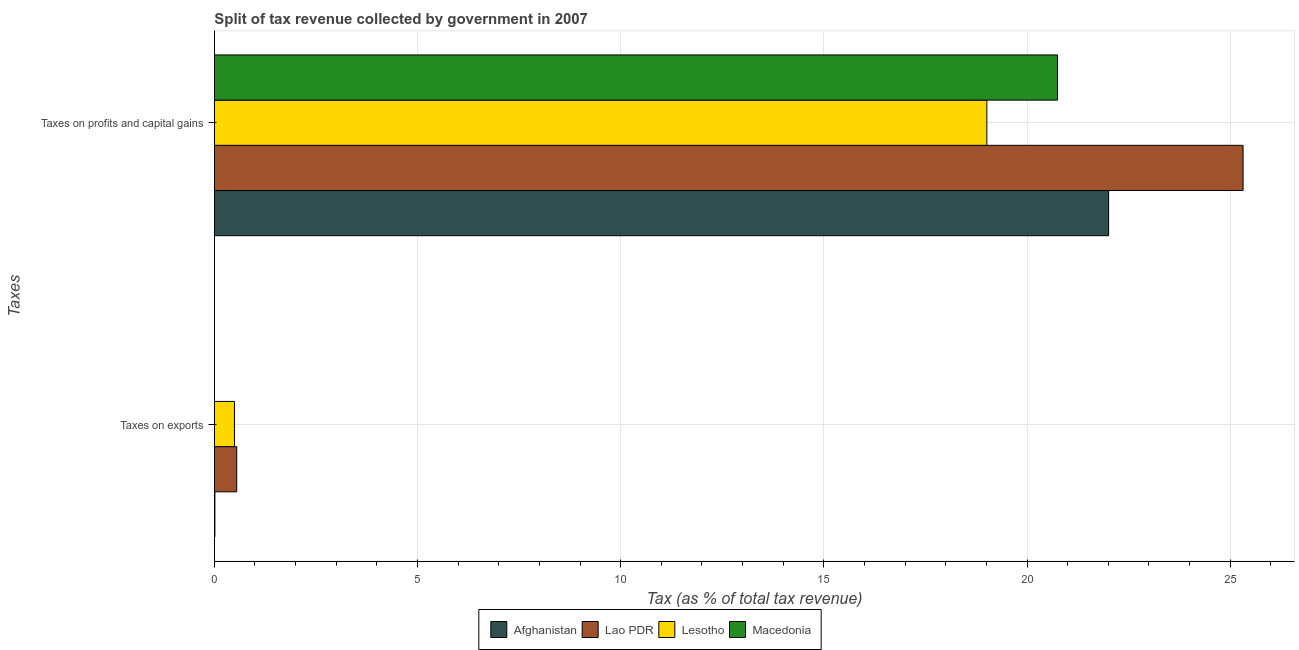Are the number of bars per tick equal to the number of legend labels?
Offer a terse response. Yes. What is the label of the 2nd group of bars from the top?
Ensure brevity in your answer.  Taxes on exports. What is the percentage of revenue obtained from taxes on exports in Lesotho?
Provide a short and direct response. 0.49. Across all countries, what is the maximum percentage of revenue obtained from taxes on exports?
Offer a very short reply. 0.55. Across all countries, what is the minimum percentage of revenue obtained from taxes on profits and capital gains?
Ensure brevity in your answer.  19.01. In which country was the percentage of revenue obtained from taxes on exports maximum?
Offer a terse response. Lao PDR. In which country was the percentage of revenue obtained from taxes on profits and capital gains minimum?
Offer a very short reply. Lesotho. What is the total percentage of revenue obtained from taxes on profits and capital gains in the graph?
Keep it short and to the point. 87.09. What is the difference between the percentage of revenue obtained from taxes on profits and capital gains in Afghanistan and that in Lesotho?
Your answer should be very brief. 3. What is the difference between the percentage of revenue obtained from taxes on profits and capital gains in Afghanistan and the percentage of revenue obtained from taxes on exports in Lesotho?
Your answer should be compact. 21.51. What is the average percentage of revenue obtained from taxes on exports per country?
Offer a very short reply. 0.26. What is the difference between the percentage of revenue obtained from taxes on profits and capital gains and percentage of revenue obtained from taxes on exports in Macedonia?
Make the answer very short. 20.75. In how many countries, is the percentage of revenue obtained from taxes on profits and capital gains greater than 22 %?
Give a very brief answer. 2. What is the ratio of the percentage of revenue obtained from taxes on profits and capital gains in Lao PDR to that in Macedonia?
Provide a short and direct response. 1.22. Is the percentage of revenue obtained from taxes on exports in Macedonia less than that in Lesotho?
Offer a very short reply. Yes. What does the 3rd bar from the top in Taxes on profits and capital gains represents?
Your answer should be compact. Lao PDR. What does the 4th bar from the bottom in Taxes on profits and capital gains represents?
Your answer should be very brief. Macedonia. How many bars are there?
Provide a succinct answer. 8. How many countries are there in the graph?
Your answer should be very brief. 4. Are the values on the major ticks of X-axis written in scientific E-notation?
Ensure brevity in your answer.  No. Does the graph contain grids?
Keep it short and to the point. Yes. Where does the legend appear in the graph?
Your response must be concise. Bottom center. How many legend labels are there?
Provide a succinct answer. 4. What is the title of the graph?
Ensure brevity in your answer.  Split of tax revenue collected by government in 2007. Does "Macao" appear as one of the legend labels in the graph?
Offer a very short reply. No. What is the label or title of the X-axis?
Provide a succinct answer. Tax (as % of total tax revenue). What is the label or title of the Y-axis?
Offer a very short reply. Taxes. What is the Tax (as % of total tax revenue) in Afghanistan in Taxes on exports?
Offer a terse response. 0.01. What is the Tax (as % of total tax revenue) of Lao PDR in Taxes on exports?
Offer a terse response. 0.55. What is the Tax (as % of total tax revenue) of Lesotho in Taxes on exports?
Give a very brief answer. 0.49. What is the Tax (as % of total tax revenue) in Macedonia in Taxes on exports?
Make the answer very short. 1.83851793347189e-5. What is the Tax (as % of total tax revenue) in Afghanistan in Taxes on profits and capital gains?
Your answer should be compact. 22.01. What is the Tax (as % of total tax revenue) in Lao PDR in Taxes on profits and capital gains?
Your answer should be very brief. 25.32. What is the Tax (as % of total tax revenue) of Lesotho in Taxes on profits and capital gains?
Your response must be concise. 19.01. What is the Tax (as % of total tax revenue) in Macedonia in Taxes on profits and capital gains?
Offer a terse response. 20.75. Across all Taxes, what is the maximum Tax (as % of total tax revenue) of Afghanistan?
Give a very brief answer. 22.01. Across all Taxes, what is the maximum Tax (as % of total tax revenue) in Lao PDR?
Offer a very short reply. 25.32. Across all Taxes, what is the maximum Tax (as % of total tax revenue) of Lesotho?
Ensure brevity in your answer.  19.01. Across all Taxes, what is the maximum Tax (as % of total tax revenue) of Macedonia?
Your response must be concise. 20.75. Across all Taxes, what is the minimum Tax (as % of total tax revenue) in Afghanistan?
Provide a short and direct response. 0.01. Across all Taxes, what is the minimum Tax (as % of total tax revenue) in Lao PDR?
Offer a terse response. 0.55. Across all Taxes, what is the minimum Tax (as % of total tax revenue) of Lesotho?
Offer a terse response. 0.49. Across all Taxes, what is the minimum Tax (as % of total tax revenue) of Macedonia?
Your answer should be compact. 1.83851793347189e-5. What is the total Tax (as % of total tax revenue) of Afghanistan in the graph?
Ensure brevity in your answer.  22.02. What is the total Tax (as % of total tax revenue) in Lao PDR in the graph?
Make the answer very short. 25.87. What is the total Tax (as % of total tax revenue) in Lesotho in the graph?
Your answer should be very brief. 19.51. What is the total Tax (as % of total tax revenue) of Macedonia in the graph?
Your answer should be compact. 20.75. What is the difference between the Tax (as % of total tax revenue) in Afghanistan in Taxes on exports and that in Taxes on profits and capital gains?
Your answer should be compact. -22. What is the difference between the Tax (as % of total tax revenue) of Lao PDR in Taxes on exports and that in Taxes on profits and capital gains?
Offer a very short reply. -24.77. What is the difference between the Tax (as % of total tax revenue) of Lesotho in Taxes on exports and that in Taxes on profits and capital gains?
Give a very brief answer. -18.52. What is the difference between the Tax (as % of total tax revenue) of Macedonia in Taxes on exports and that in Taxes on profits and capital gains?
Provide a short and direct response. -20.75. What is the difference between the Tax (as % of total tax revenue) in Afghanistan in Taxes on exports and the Tax (as % of total tax revenue) in Lao PDR in Taxes on profits and capital gains?
Provide a short and direct response. -25.3. What is the difference between the Tax (as % of total tax revenue) in Afghanistan in Taxes on exports and the Tax (as % of total tax revenue) in Lesotho in Taxes on profits and capital gains?
Your answer should be very brief. -19. What is the difference between the Tax (as % of total tax revenue) in Afghanistan in Taxes on exports and the Tax (as % of total tax revenue) in Macedonia in Taxes on profits and capital gains?
Give a very brief answer. -20.74. What is the difference between the Tax (as % of total tax revenue) in Lao PDR in Taxes on exports and the Tax (as % of total tax revenue) in Lesotho in Taxes on profits and capital gains?
Your answer should be very brief. -18.46. What is the difference between the Tax (as % of total tax revenue) of Lao PDR in Taxes on exports and the Tax (as % of total tax revenue) of Macedonia in Taxes on profits and capital gains?
Your answer should be very brief. -20.2. What is the difference between the Tax (as % of total tax revenue) in Lesotho in Taxes on exports and the Tax (as % of total tax revenue) in Macedonia in Taxes on profits and capital gains?
Keep it short and to the point. -20.26. What is the average Tax (as % of total tax revenue) of Afghanistan per Taxes?
Your response must be concise. 11.01. What is the average Tax (as % of total tax revenue) in Lao PDR per Taxes?
Ensure brevity in your answer.  12.93. What is the average Tax (as % of total tax revenue) of Lesotho per Taxes?
Offer a very short reply. 9.75. What is the average Tax (as % of total tax revenue) of Macedonia per Taxes?
Ensure brevity in your answer.  10.38. What is the difference between the Tax (as % of total tax revenue) of Afghanistan and Tax (as % of total tax revenue) of Lao PDR in Taxes on exports?
Offer a very short reply. -0.54. What is the difference between the Tax (as % of total tax revenue) in Afghanistan and Tax (as % of total tax revenue) in Lesotho in Taxes on exports?
Provide a succinct answer. -0.48. What is the difference between the Tax (as % of total tax revenue) in Afghanistan and Tax (as % of total tax revenue) in Macedonia in Taxes on exports?
Give a very brief answer. 0.01. What is the difference between the Tax (as % of total tax revenue) in Lao PDR and Tax (as % of total tax revenue) in Lesotho in Taxes on exports?
Provide a short and direct response. 0.06. What is the difference between the Tax (as % of total tax revenue) in Lao PDR and Tax (as % of total tax revenue) in Macedonia in Taxes on exports?
Offer a very short reply. 0.55. What is the difference between the Tax (as % of total tax revenue) in Lesotho and Tax (as % of total tax revenue) in Macedonia in Taxes on exports?
Your answer should be compact. 0.49. What is the difference between the Tax (as % of total tax revenue) in Afghanistan and Tax (as % of total tax revenue) in Lao PDR in Taxes on profits and capital gains?
Your response must be concise. -3.31. What is the difference between the Tax (as % of total tax revenue) in Afghanistan and Tax (as % of total tax revenue) in Lesotho in Taxes on profits and capital gains?
Your response must be concise. 3. What is the difference between the Tax (as % of total tax revenue) in Afghanistan and Tax (as % of total tax revenue) in Macedonia in Taxes on profits and capital gains?
Offer a terse response. 1.26. What is the difference between the Tax (as % of total tax revenue) in Lao PDR and Tax (as % of total tax revenue) in Lesotho in Taxes on profits and capital gains?
Give a very brief answer. 6.3. What is the difference between the Tax (as % of total tax revenue) of Lao PDR and Tax (as % of total tax revenue) of Macedonia in Taxes on profits and capital gains?
Your answer should be very brief. 4.57. What is the difference between the Tax (as % of total tax revenue) of Lesotho and Tax (as % of total tax revenue) of Macedonia in Taxes on profits and capital gains?
Provide a short and direct response. -1.74. What is the ratio of the Tax (as % of total tax revenue) in Afghanistan in Taxes on exports to that in Taxes on profits and capital gains?
Offer a very short reply. 0. What is the ratio of the Tax (as % of total tax revenue) of Lao PDR in Taxes on exports to that in Taxes on profits and capital gains?
Your answer should be very brief. 0.02. What is the ratio of the Tax (as % of total tax revenue) in Lesotho in Taxes on exports to that in Taxes on profits and capital gains?
Offer a terse response. 0.03. What is the ratio of the Tax (as % of total tax revenue) of Macedonia in Taxes on exports to that in Taxes on profits and capital gains?
Ensure brevity in your answer.  0. What is the difference between the highest and the second highest Tax (as % of total tax revenue) of Afghanistan?
Keep it short and to the point. 22. What is the difference between the highest and the second highest Tax (as % of total tax revenue) in Lao PDR?
Give a very brief answer. 24.77. What is the difference between the highest and the second highest Tax (as % of total tax revenue) in Lesotho?
Offer a terse response. 18.52. What is the difference between the highest and the second highest Tax (as % of total tax revenue) in Macedonia?
Your answer should be compact. 20.75. What is the difference between the highest and the lowest Tax (as % of total tax revenue) in Afghanistan?
Offer a terse response. 22. What is the difference between the highest and the lowest Tax (as % of total tax revenue) of Lao PDR?
Your response must be concise. 24.77. What is the difference between the highest and the lowest Tax (as % of total tax revenue) of Lesotho?
Offer a very short reply. 18.52. What is the difference between the highest and the lowest Tax (as % of total tax revenue) of Macedonia?
Your response must be concise. 20.75. 